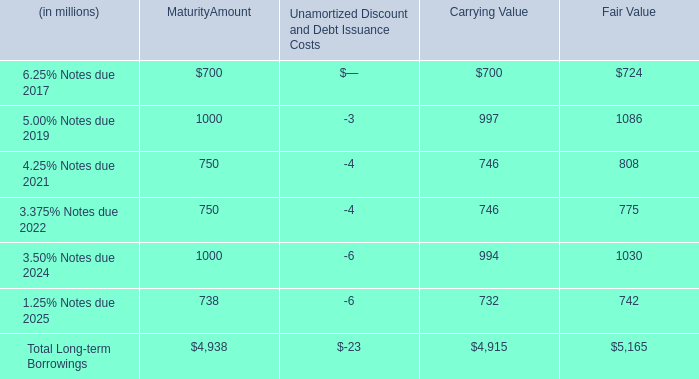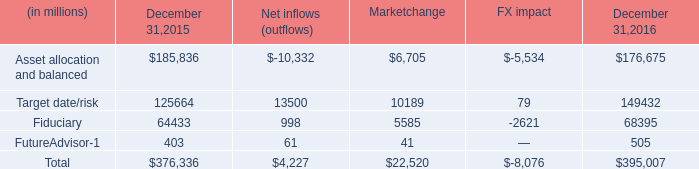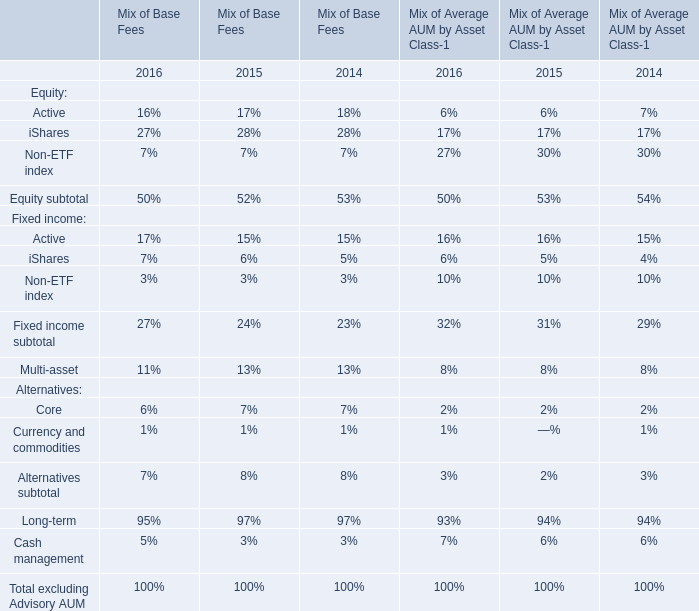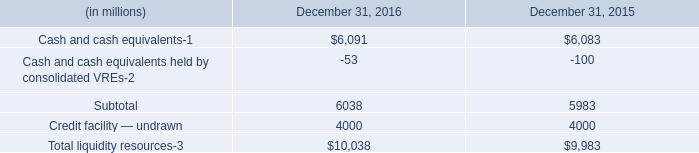What is the average amount of Target date/risk of Marketchange, and Cash and cash equivalents of December 31, 2015 ? 
Computations: ((10189.0 + 6083.0) / 2)
Answer: 8136.0. 